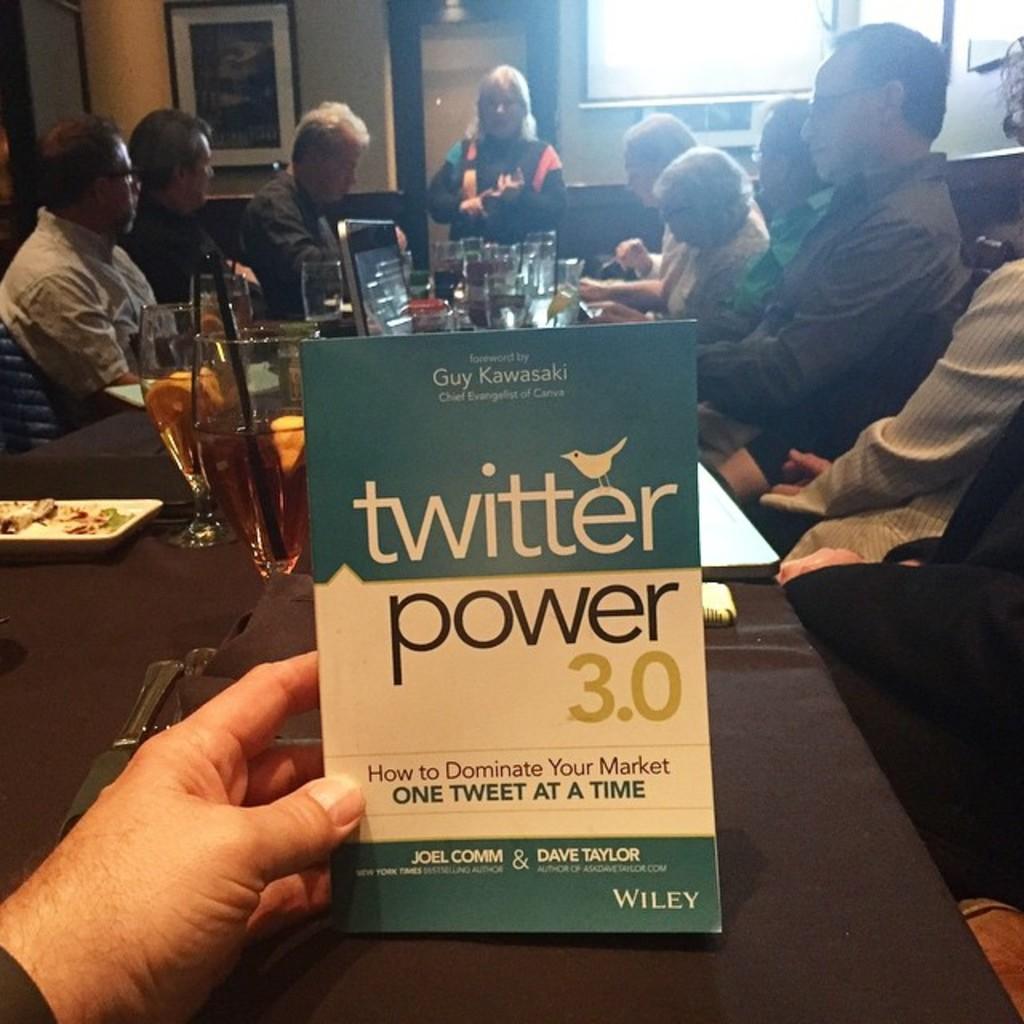How would you summarize this image in a sentence or two? In this picture there are people sitting on chairs at the table. A cloth is spread on the table. On the table there are glasses with drink and straw in it and plates with food in it. At the center there is a person holding a paper in his hand. In the background there is a door, wall, window and picture frame hanging on the wall. 